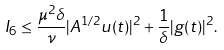Convert formula to latex. <formula><loc_0><loc_0><loc_500><loc_500>I _ { 6 } \leq \frac { \mu ^ { 2 } \delta } { \nu } | A ^ { 1 / 2 } u ( t ) | ^ { 2 } + \frac { 1 } { \delta } | g ( t ) | ^ { 2 } .</formula> 